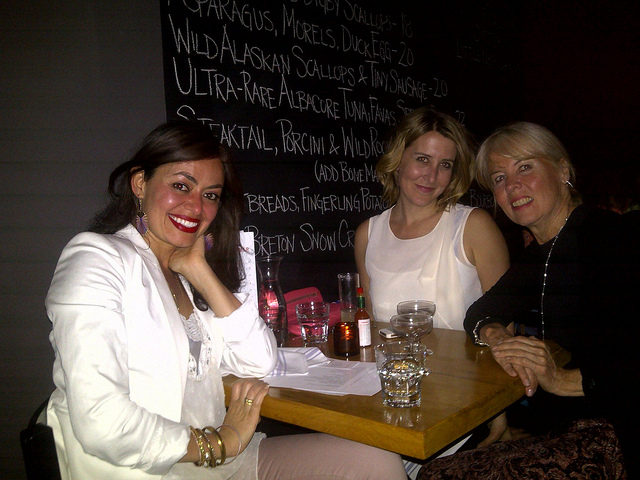<image>What does it say on the glass in her left hand? It is unknown what it says on the glass in her left hand. It is stated that there might be nothing on the glass. What does it say on the glass in her left hand? It is unclear what it says on the glass in her left hand. It can be nothing or it can be something that is not visible in the image. 